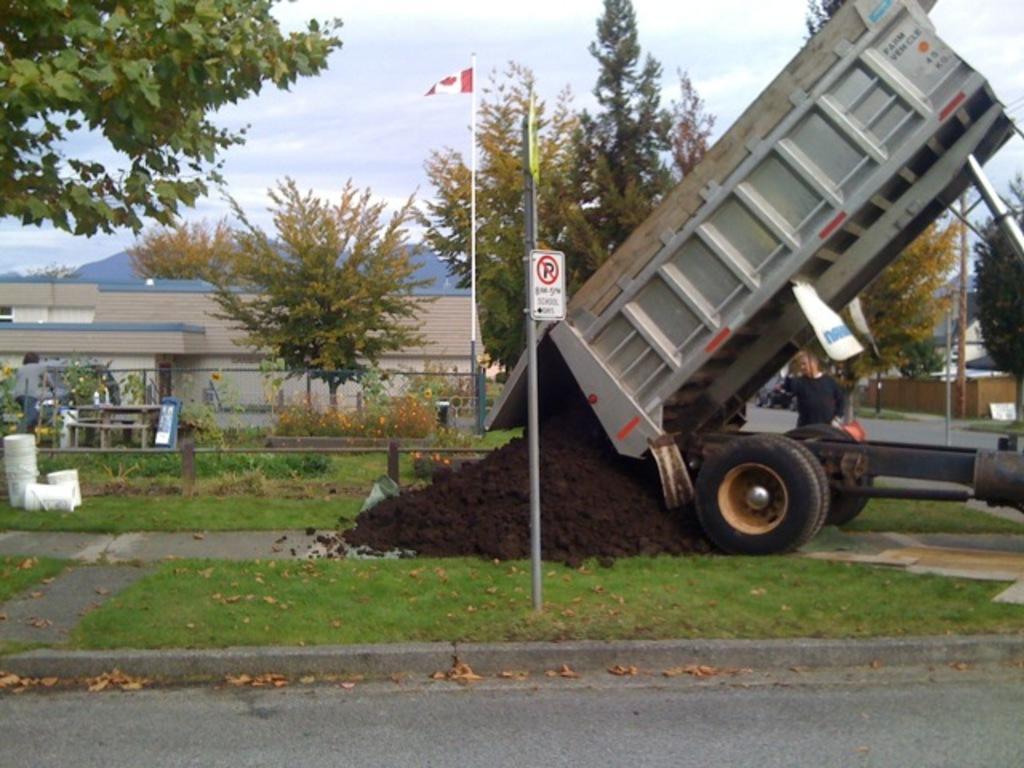Please provide a concise description of this image. There is a road. On the ground there is grass. There is a truck with soil. Near to that there is a pole with a sign board. Also there is a flag with a pole. There are trees. There is a building. In the background there is sky. There are buckets. Also there is a person standing. 